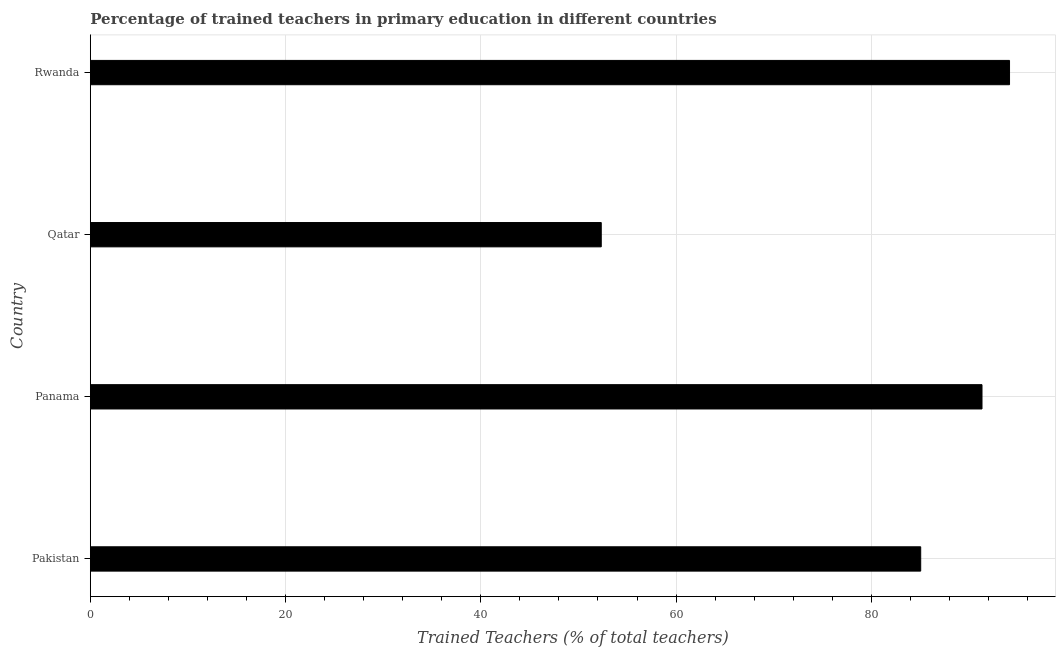Does the graph contain grids?
Your response must be concise. Yes. What is the title of the graph?
Offer a terse response. Percentage of trained teachers in primary education in different countries. What is the label or title of the X-axis?
Offer a very short reply. Trained Teachers (% of total teachers). What is the percentage of trained teachers in Rwanda?
Provide a succinct answer. 94.16. Across all countries, what is the maximum percentage of trained teachers?
Provide a succinct answer. 94.16. Across all countries, what is the minimum percentage of trained teachers?
Your answer should be very brief. 52.34. In which country was the percentage of trained teachers maximum?
Your response must be concise. Rwanda. In which country was the percentage of trained teachers minimum?
Make the answer very short. Qatar. What is the sum of the percentage of trained teachers?
Provide a succinct answer. 322.9. What is the difference between the percentage of trained teachers in Qatar and Rwanda?
Make the answer very short. -41.83. What is the average percentage of trained teachers per country?
Your answer should be compact. 80.73. What is the median percentage of trained teachers?
Provide a succinct answer. 88.2. What is the ratio of the percentage of trained teachers in Panama to that in Rwanda?
Provide a short and direct response. 0.97. Is the percentage of trained teachers in Pakistan less than that in Rwanda?
Provide a short and direct response. Yes. Is the difference between the percentage of trained teachers in Pakistan and Panama greater than the difference between any two countries?
Provide a short and direct response. No. What is the difference between the highest and the second highest percentage of trained teachers?
Your answer should be compact. 2.82. What is the difference between the highest and the lowest percentage of trained teachers?
Make the answer very short. 41.82. In how many countries, is the percentage of trained teachers greater than the average percentage of trained teachers taken over all countries?
Offer a terse response. 3. How many bars are there?
Ensure brevity in your answer.  4. Are all the bars in the graph horizontal?
Your answer should be compact. Yes. What is the Trained Teachers (% of total teachers) of Pakistan?
Provide a succinct answer. 85.06. What is the Trained Teachers (% of total teachers) in Panama?
Your answer should be very brief. 91.34. What is the Trained Teachers (% of total teachers) of Qatar?
Provide a short and direct response. 52.34. What is the Trained Teachers (% of total teachers) in Rwanda?
Your answer should be compact. 94.16. What is the difference between the Trained Teachers (% of total teachers) in Pakistan and Panama?
Ensure brevity in your answer.  -6.28. What is the difference between the Trained Teachers (% of total teachers) in Pakistan and Qatar?
Your answer should be compact. 32.73. What is the difference between the Trained Teachers (% of total teachers) in Pakistan and Rwanda?
Your answer should be compact. -9.1. What is the difference between the Trained Teachers (% of total teachers) in Panama and Qatar?
Your answer should be very brief. 39.01. What is the difference between the Trained Teachers (% of total teachers) in Panama and Rwanda?
Your answer should be very brief. -2.82. What is the difference between the Trained Teachers (% of total teachers) in Qatar and Rwanda?
Your answer should be compact. -41.82. What is the ratio of the Trained Teachers (% of total teachers) in Pakistan to that in Qatar?
Keep it short and to the point. 1.62. What is the ratio of the Trained Teachers (% of total teachers) in Pakistan to that in Rwanda?
Offer a very short reply. 0.9. What is the ratio of the Trained Teachers (% of total teachers) in Panama to that in Qatar?
Provide a succinct answer. 1.75. What is the ratio of the Trained Teachers (% of total teachers) in Panama to that in Rwanda?
Offer a very short reply. 0.97. What is the ratio of the Trained Teachers (% of total teachers) in Qatar to that in Rwanda?
Make the answer very short. 0.56. 